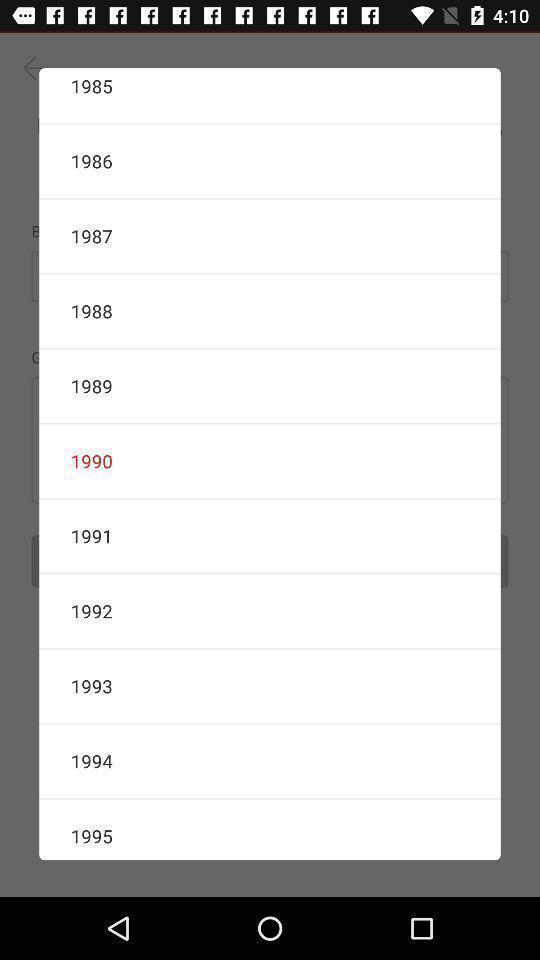Explain the elements present in this screenshot. Pop-up displaying the list of years. 